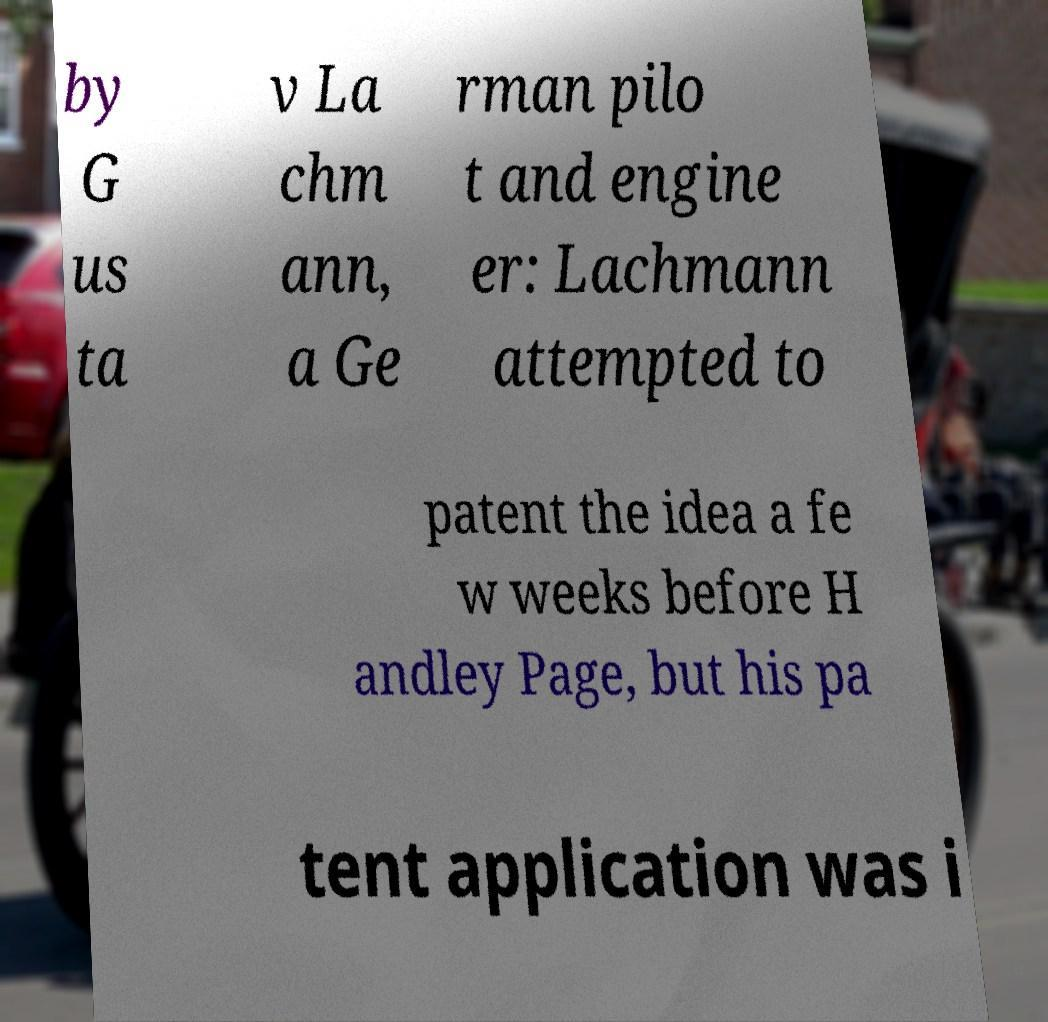What messages or text are displayed in this image? I need them in a readable, typed format. by G us ta v La chm ann, a Ge rman pilo t and engine er: Lachmann attempted to patent the idea a fe w weeks before H andley Page, but his pa tent application was i 